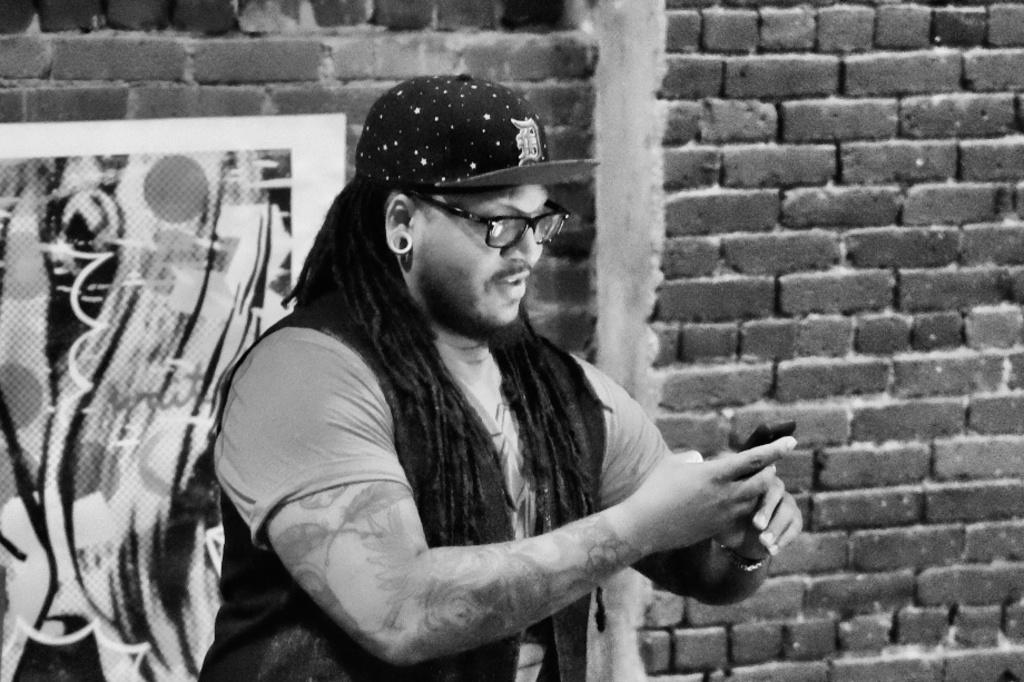Who is the main subject in the picture? There is a man in the center of the picture. What is the man wearing on his face? The man is wearing spectacles. What is the man wearing on his head? The man is wearing a cap. What is the man holding in his hand? The man is holding a phone. What can be seen on the left side of the picture? There is a poster on the left side of the picture. What type of wall is visible in the background of the picture? There is a brick wall in the background of the picture. What type of secretary is sitting on the man's lap in the image? There is no secretary present in the image; it only features a man wearing spectacles, a cap, and holding a phone. What is the man using to touch the phone in the image? The man is not using any specific tool to touch the phone; he is likely using his fingers. 